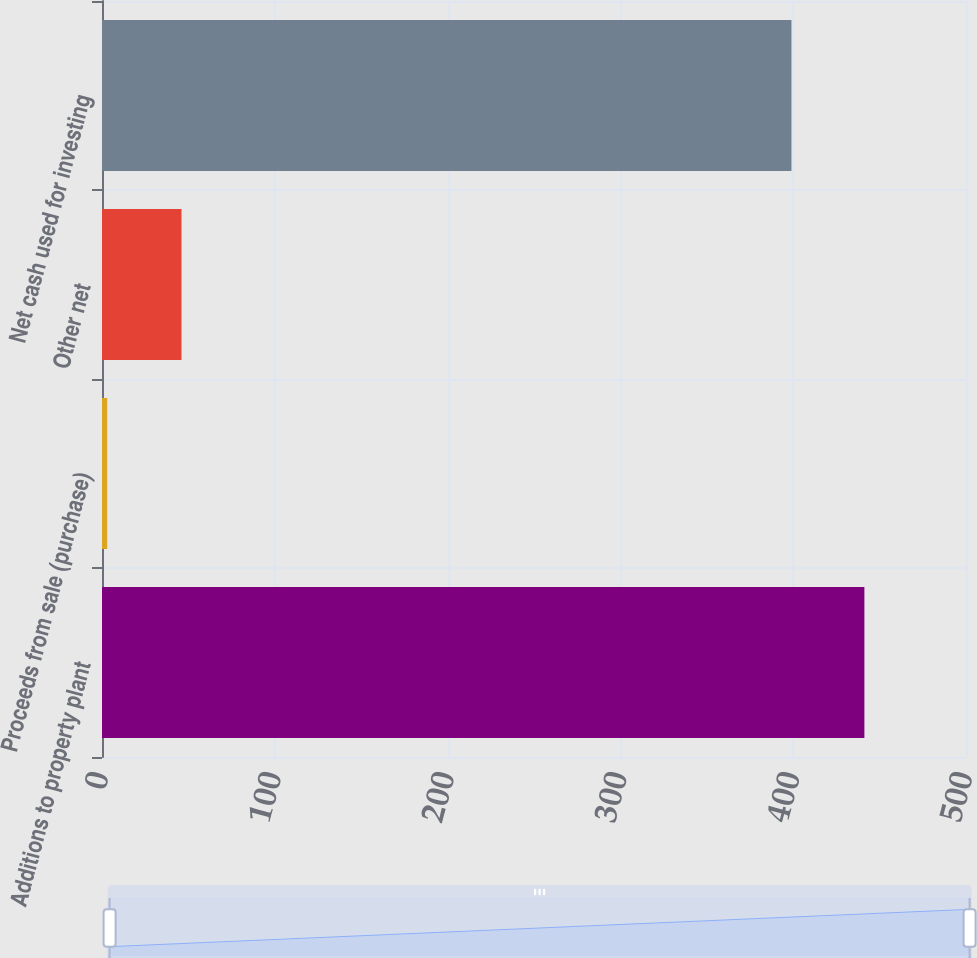<chart> <loc_0><loc_0><loc_500><loc_500><bar_chart><fcel>Additions to property plant<fcel>Proceeds from sale (purchase)<fcel>Other net<fcel>Net cash used for investing<nl><fcel>441.2<fcel>3<fcel>46<fcel>399<nl></chart> 